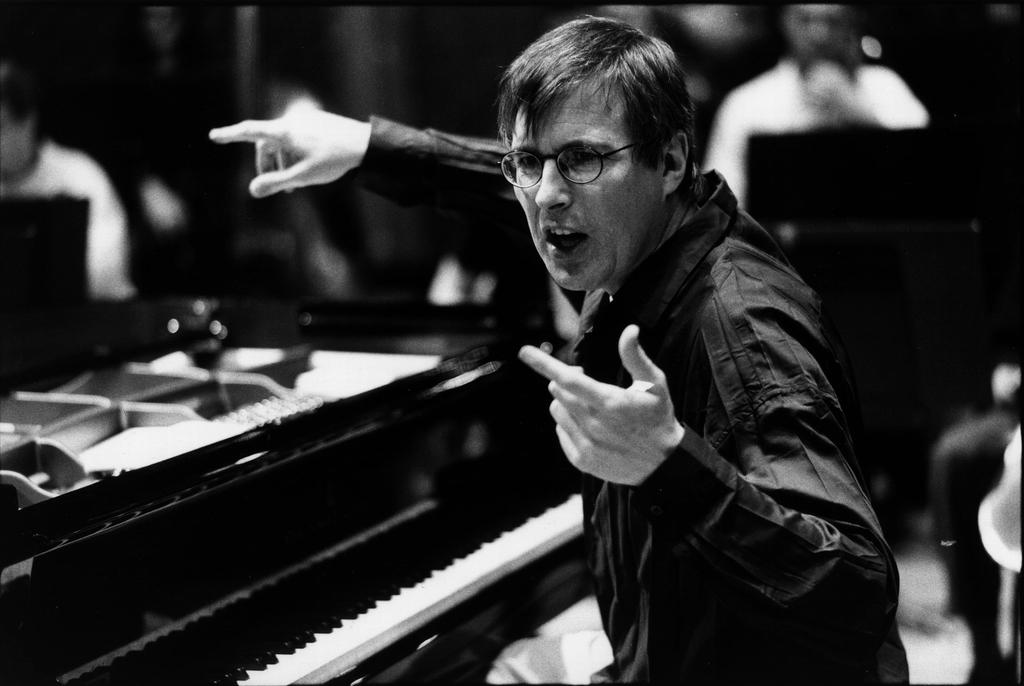What is the color scheme of the image? The image is black and white. Who is present in the image? There is a man in the image. What is the man doing in the image? The man is sitting in front of a piano keyboard. What accessory is the man wearing in the image? The man is wearing spectacles. Are there any dinosaurs visible in the image? No, there are no dinosaurs present in the image. What specific detail can be seen on the piano keyboard in the image? The provided facts do not mention any specific details about the piano keyboard, so we cannot answer this question definitively. 